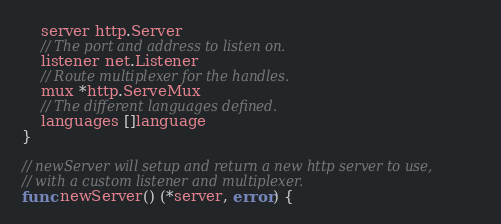<code> <loc_0><loc_0><loc_500><loc_500><_Go_>	server http.Server
	// The port and address to listen on.
	listener net.Listener
	// Route multiplexer for the handles.
	mux *http.ServeMux
	// The different languages defined.
	languages []language
}

// newServer will setup and return a new http server to use,
// with a custom listener and multiplexer.
func newServer() (*server, error) {</code> 